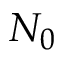<formula> <loc_0><loc_0><loc_500><loc_500>N _ { 0 }</formula> 